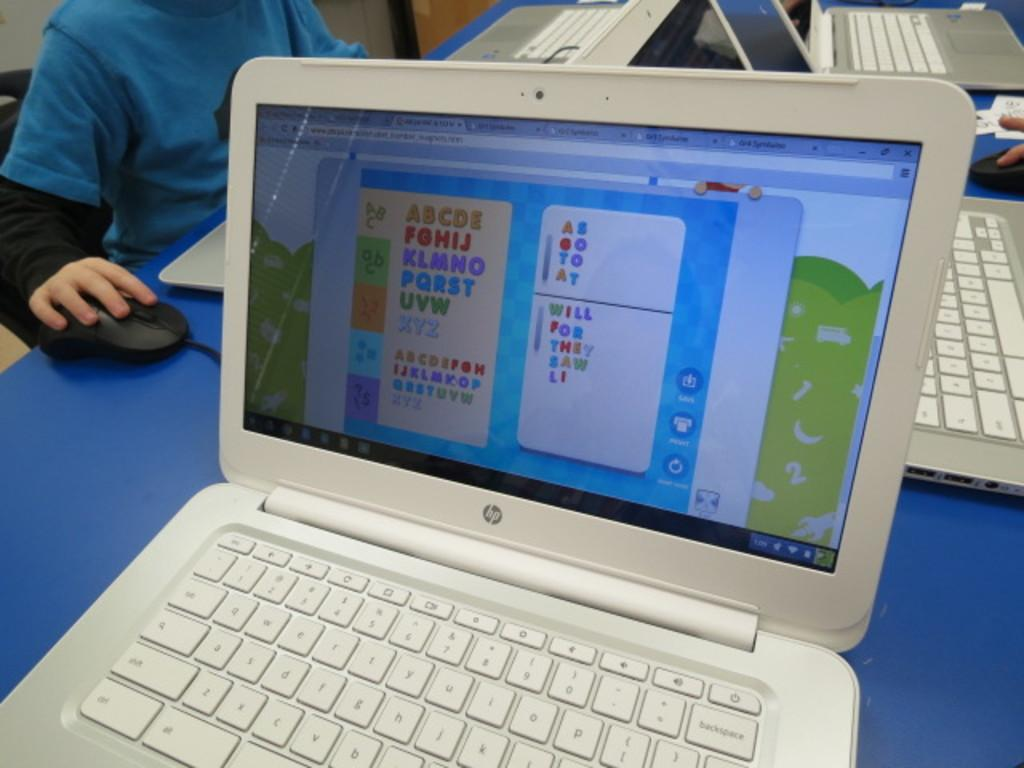<image>
Render a clear and concise summary of the photo. An HP laptop displays the English alphabet on the screen. 